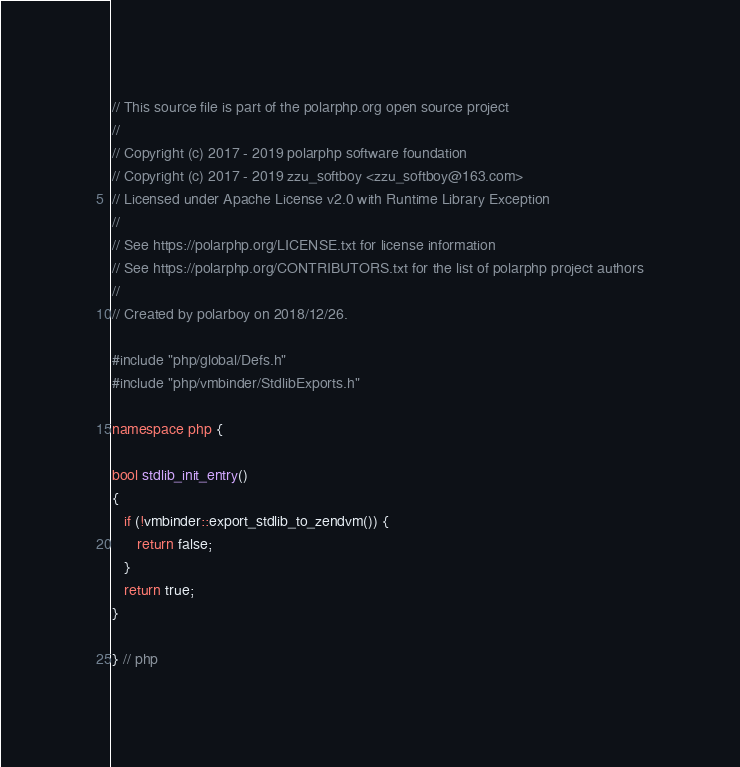Convert code to text. <code><loc_0><loc_0><loc_500><loc_500><_C++_>// This source file is part of the polarphp.org open source project
//
// Copyright (c) 2017 - 2019 polarphp software foundation
// Copyright (c) 2017 - 2019 zzu_softboy <zzu_softboy@163.com>
// Licensed under Apache License v2.0 with Runtime Library Exception
//
// See https://polarphp.org/LICENSE.txt for license information
// See https://polarphp.org/CONTRIBUTORS.txt for the list of polarphp project authors
//
// Created by polarboy on 2018/12/26.

#include "php/global/Defs.h"
#include "php/vmbinder/StdlibExports.h"

namespace php {

bool stdlib_init_entry()
{
   if (!vmbinder::export_stdlib_to_zendvm()) {
      return false;
   }
   return true;
}

} // php
</code> 